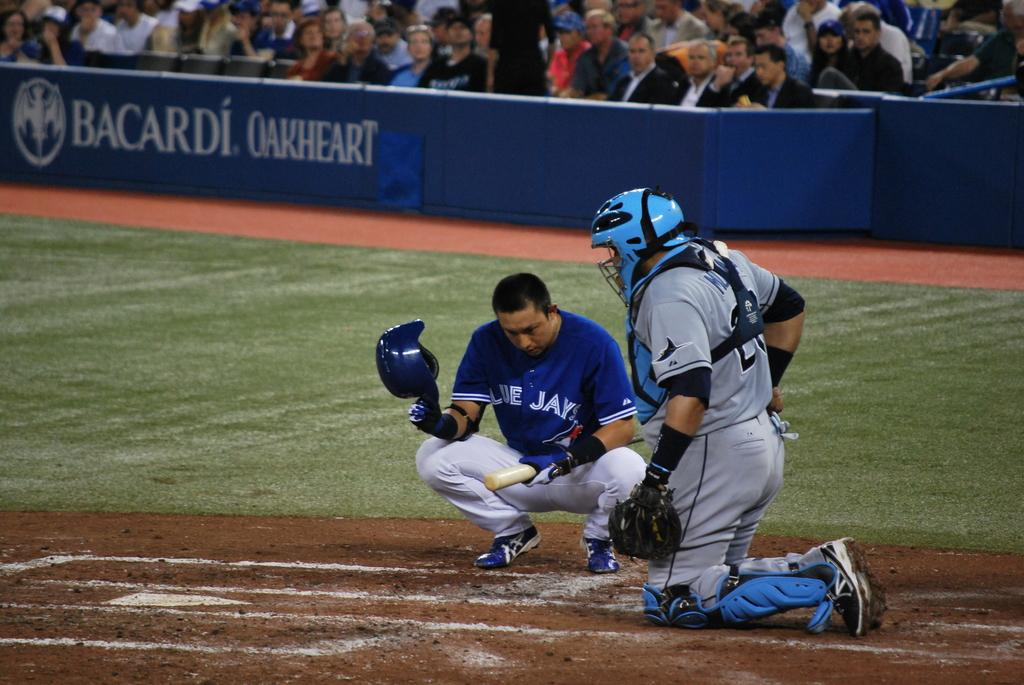<image>
Provide a brief description of the given image. Man wearing a Blue Jays jersey and kneeling on the plate. 